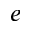<formula> <loc_0><loc_0><loc_500><loc_500>^ { e }</formula> 